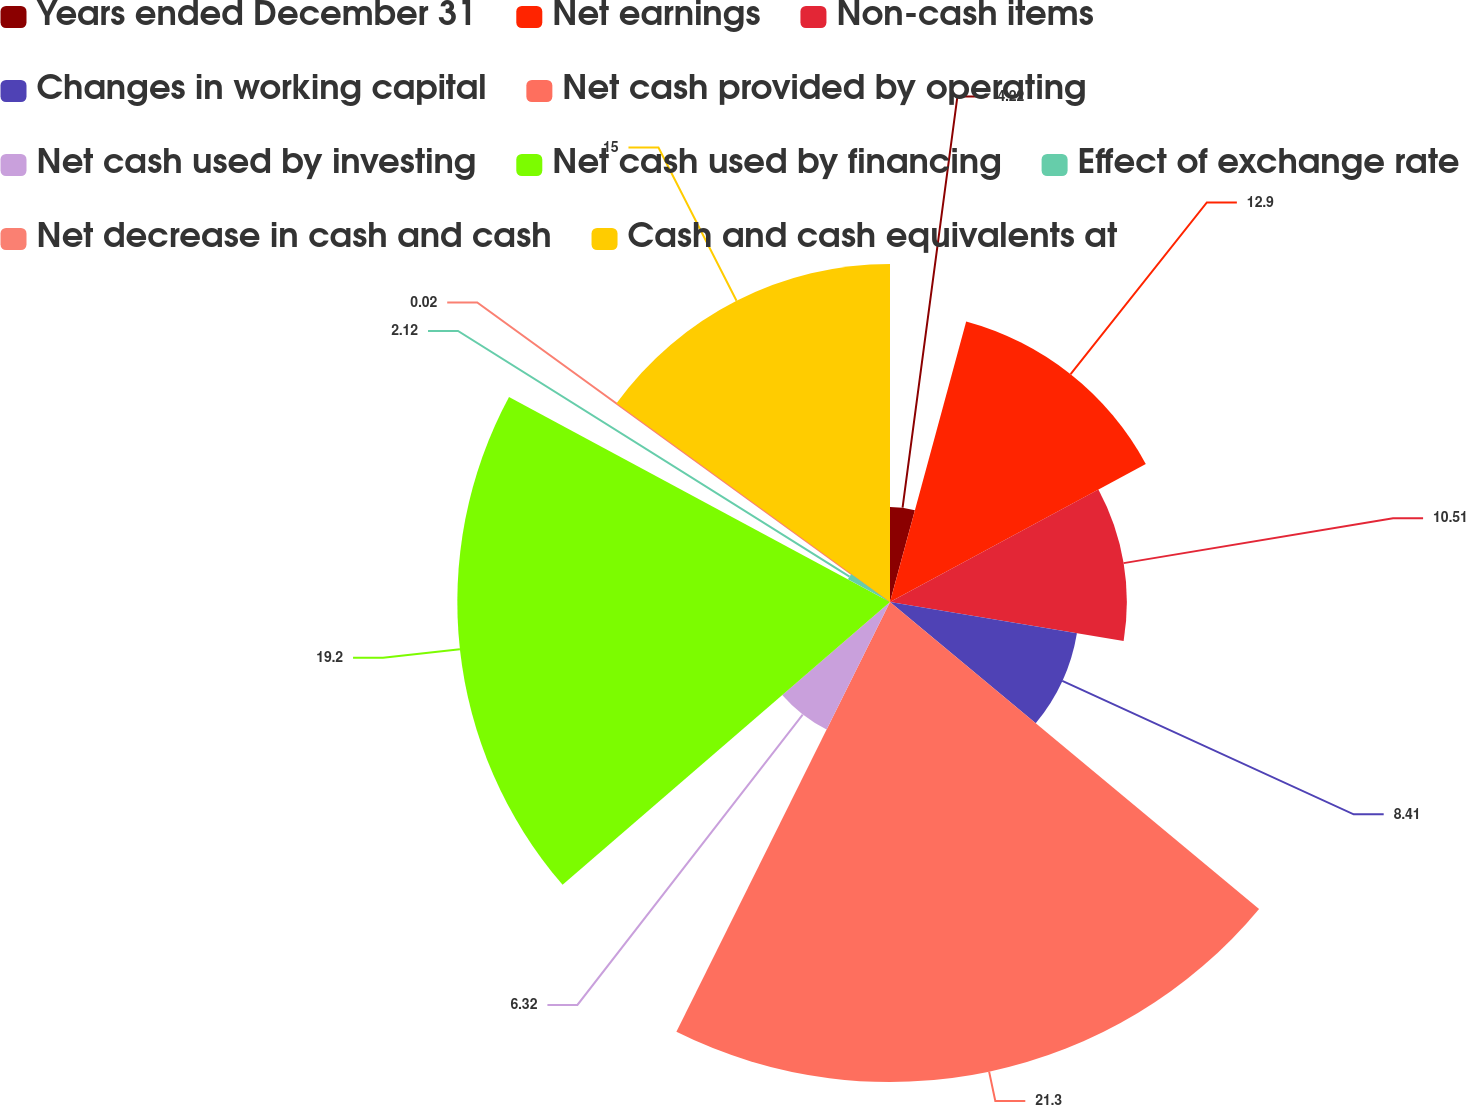Convert chart to OTSL. <chart><loc_0><loc_0><loc_500><loc_500><pie_chart><fcel>Years ended December 31<fcel>Net earnings<fcel>Non-cash items<fcel>Changes in working capital<fcel>Net cash provided by operating<fcel>Net cash used by investing<fcel>Net cash used by financing<fcel>Effect of exchange rate<fcel>Net decrease in cash and cash<fcel>Cash and cash equivalents at<nl><fcel>4.22%<fcel>12.9%<fcel>10.51%<fcel>8.41%<fcel>21.3%<fcel>6.32%<fcel>19.2%<fcel>2.12%<fcel>0.02%<fcel>15.0%<nl></chart> 